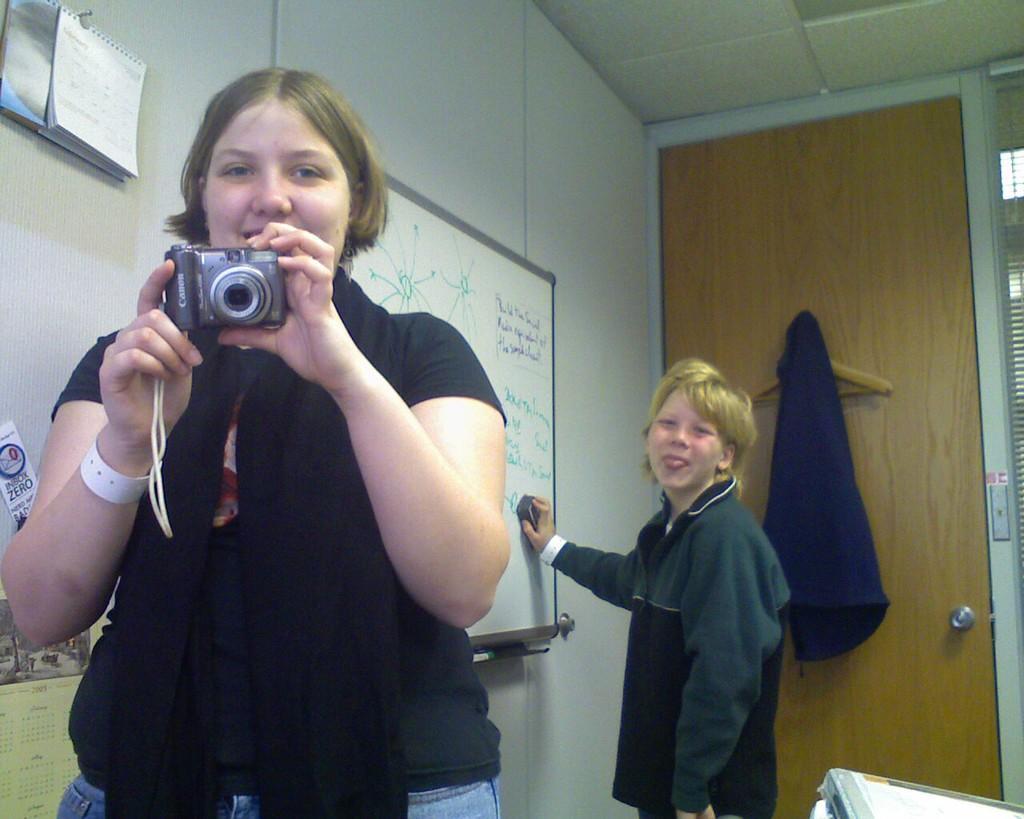In one or two sentences, can you explain what this image depicts? On the background we can see a wall , whiteboard , door and a jacket over it. Here we can see one boy rubbing the board. We can see one woman holding a camera in her hand. this is a calendar. 